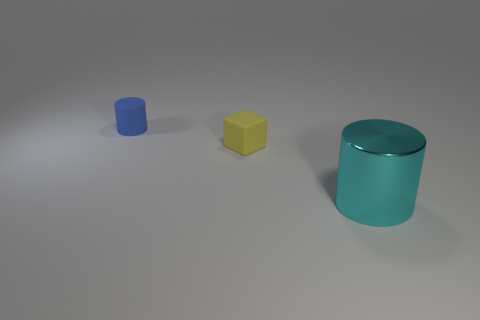Subtract all green blocks. Subtract all yellow spheres. How many blocks are left? 1 Add 2 large cylinders. How many objects exist? 5 Subtract all cylinders. How many objects are left? 1 Subtract all large gray rubber cylinders. Subtract all cyan metal things. How many objects are left? 2 Add 2 shiny cylinders. How many shiny cylinders are left? 3 Add 3 large purple matte objects. How many large purple matte objects exist? 3 Subtract 0 red spheres. How many objects are left? 3 